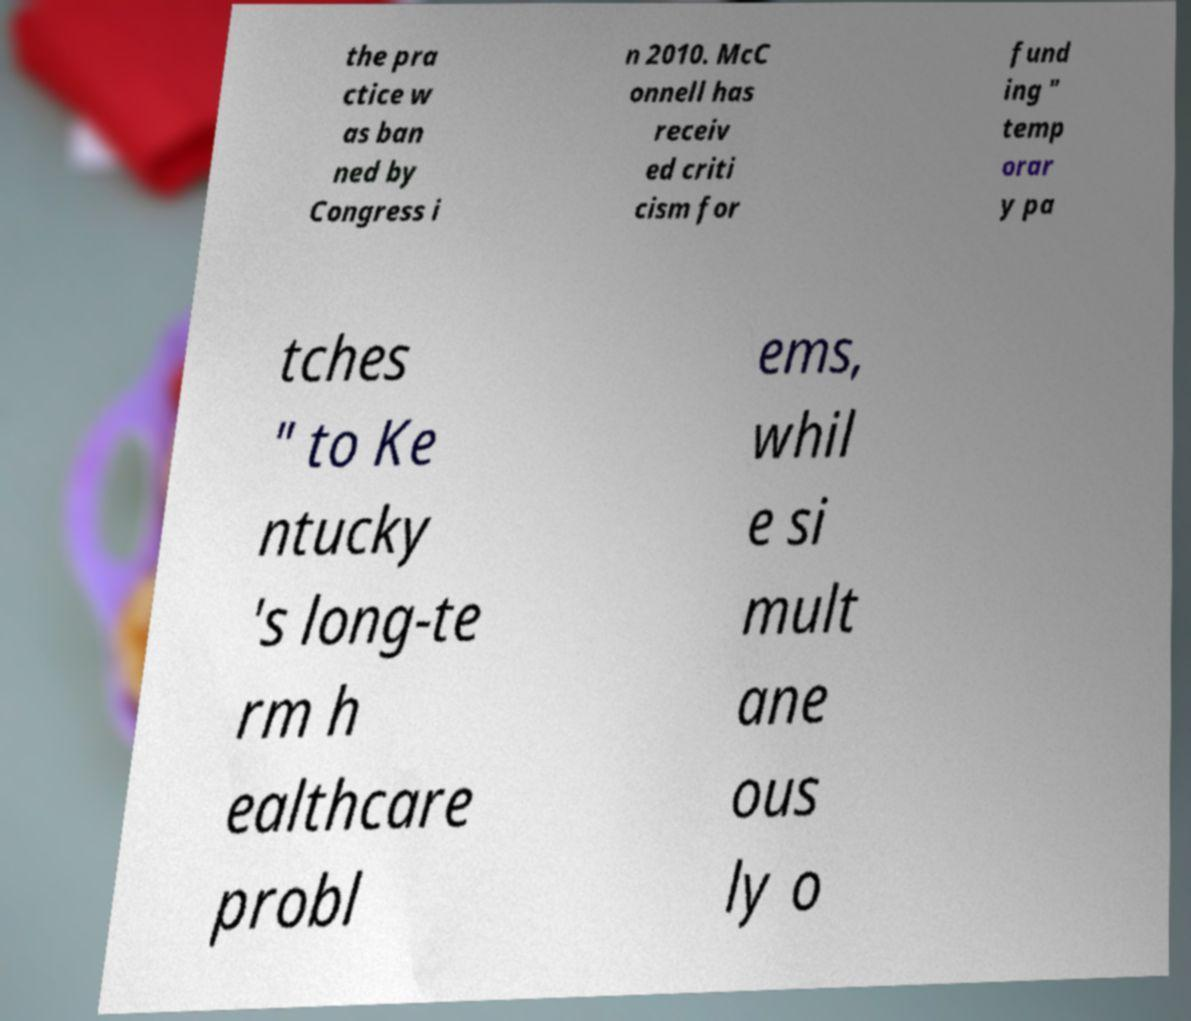Could you extract and type out the text from this image? the pra ctice w as ban ned by Congress i n 2010. McC onnell has receiv ed criti cism for fund ing " temp orar y pa tches " to Ke ntucky 's long-te rm h ealthcare probl ems, whil e si mult ane ous ly o 